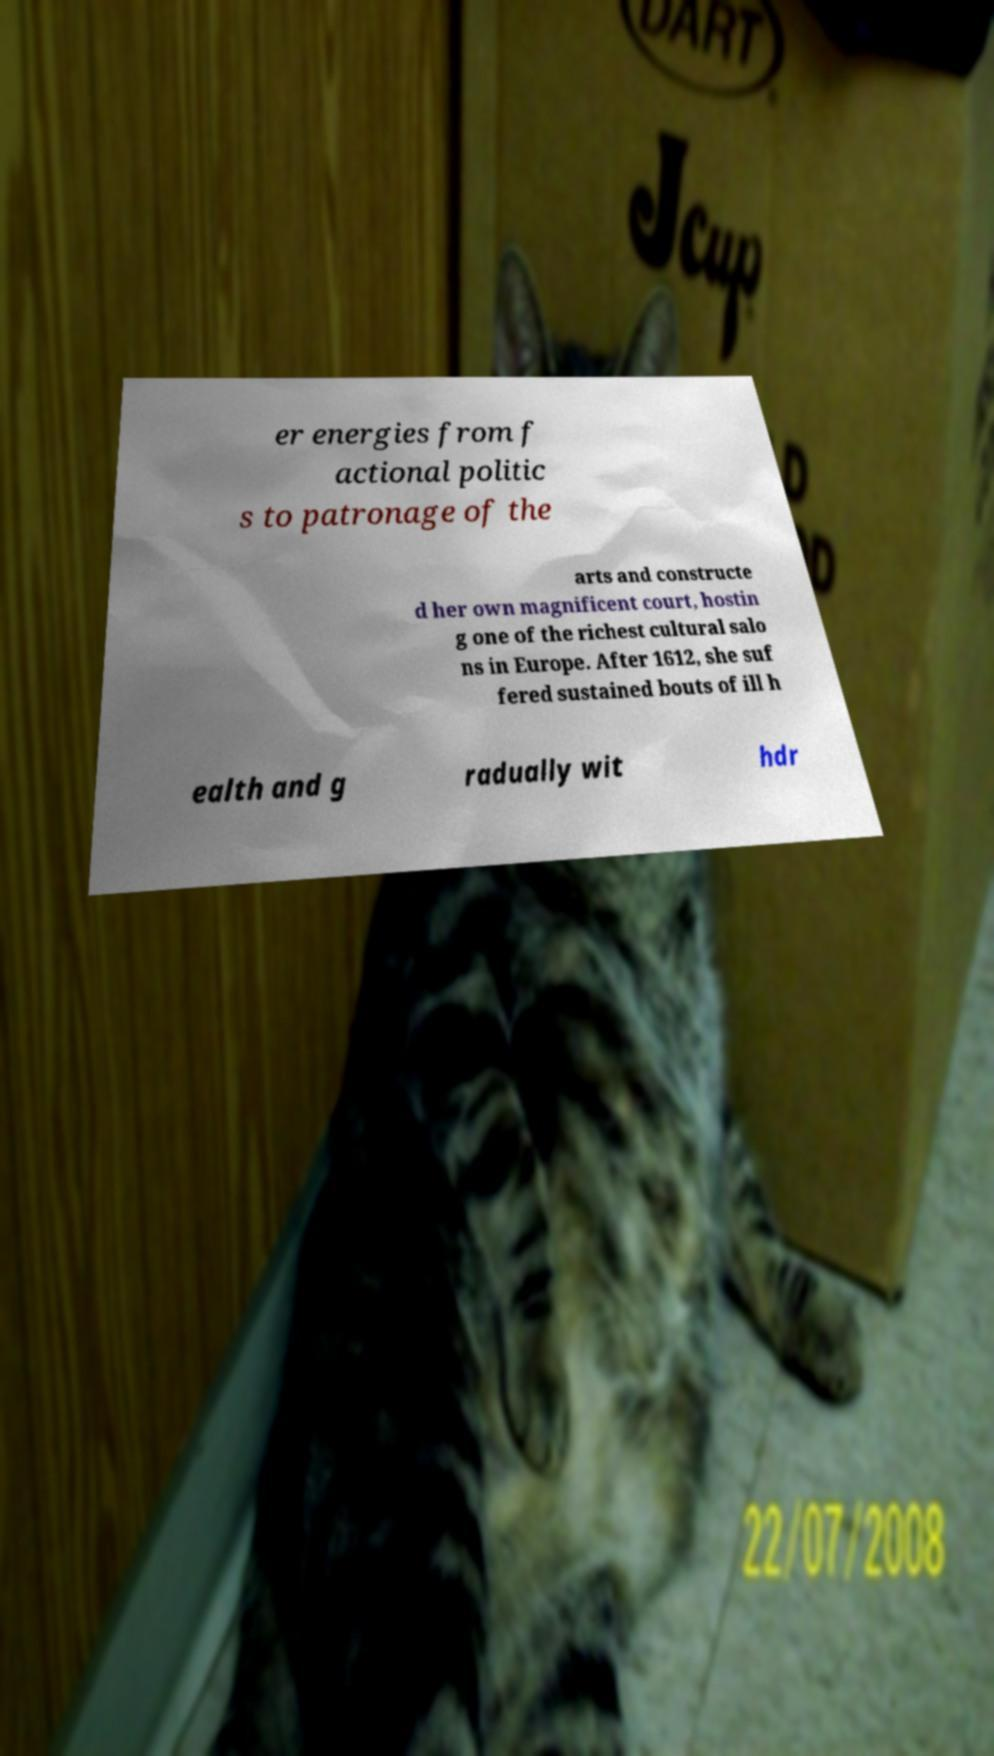Could you assist in decoding the text presented in this image and type it out clearly? er energies from f actional politic s to patronage of the arts and constructe d her own magnificent court, hostin g one of the richest cultural salo ns in Europe. After 1612, she suf fered sustained bouts of ill h ealth and g radually wit hdr 